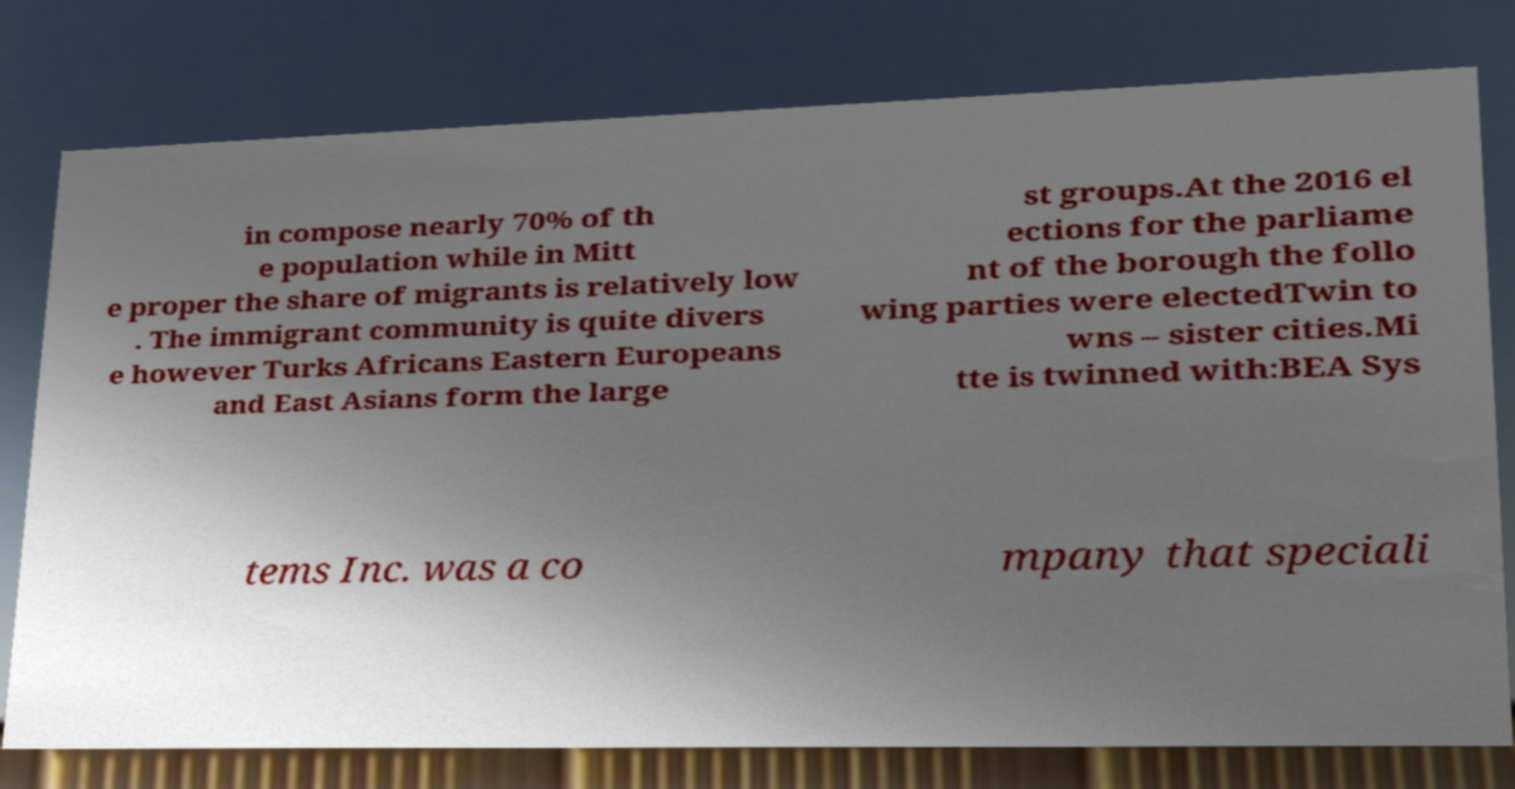For documentation purposes, I need the text within this image transcribed. Could you provide that? in compose nearly 70% of th e population while in Mitt e proper the share of migrants is relatively low . The immigrant community is quite divers e however Turks Africans Eastern Europeans and East Asians form the large st groups.At the 2016 el ections for the parliame nt of the borough the follo wing parties were electedTwin to wns – sister cities.Mi tte is twinned with:BEA Sys tems Inc. was a co mpany that speciali 